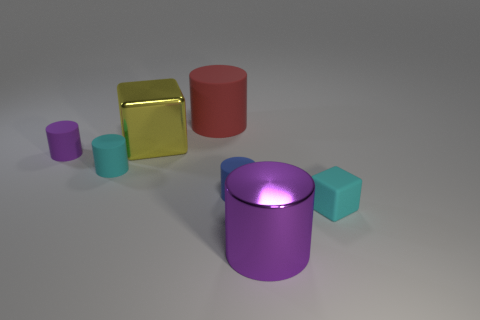There is a cyan rubber thing that is left of the large red rubber thing; is it the same shape as the big purple thing?
Provide a short and direct response. Yes. Is the number of big red matte cylinders that are on the right side of the red matte thing greater than the number of big shiny spheres?
Offer a terse response. No. Is there any other thing that is made of the same material as the cyan cube?
Provide a succinct answer. Yes. What is the shape of the small thing that is the same color as the tiny block?
Offer a terse response. Cylinder. What number of cylinders are rubber things or purple matte objects?
Offer a terse response. 4. There is a cube that is behind the matte cube right of the large yellow shiny block; what color is it?
Ensure brevity in your answer.  Yellow. Do the tiny cube and the cylinder that is to the right of the blue matte thing have the same color?
Provide a succinct answer. No. What size is the cylinder that is made of the same material as the yellow block?
Offer a terse response. Large. There is another cylinder that is the same color as the shiny cylinder; what size is it?
Keep it short and to the point. Small. Is the big rubber object the same color as the large metallic block?
Your answer should be compact. No. 